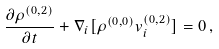Convert formula to latex. <formula><loc_0><loc_0><loc_500><loc_500>\frac { \partial \rho ^ { ( 0 , 2 ) } } { \partial t } + \nabla _ { i } [ \rho ^ { ( 0 , 0 ) } v _ { i } ^ { ( 0 , 2 ) } ] = 0 \, ,</formula> 